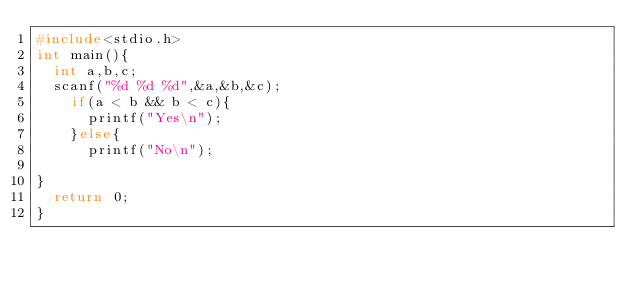Convert code to text. <code><loc_0><loc_0><loc_500><loc_500><_C_>#include<stdio.h>
int main(){
  int a,b,c;
  scanf("%d %d %d",&a,&b,&c);
    if(a < b && b < c){
      printf("Yes\n");
	}else{
      printf("No\n");

}
  return 0;
}


</code> 